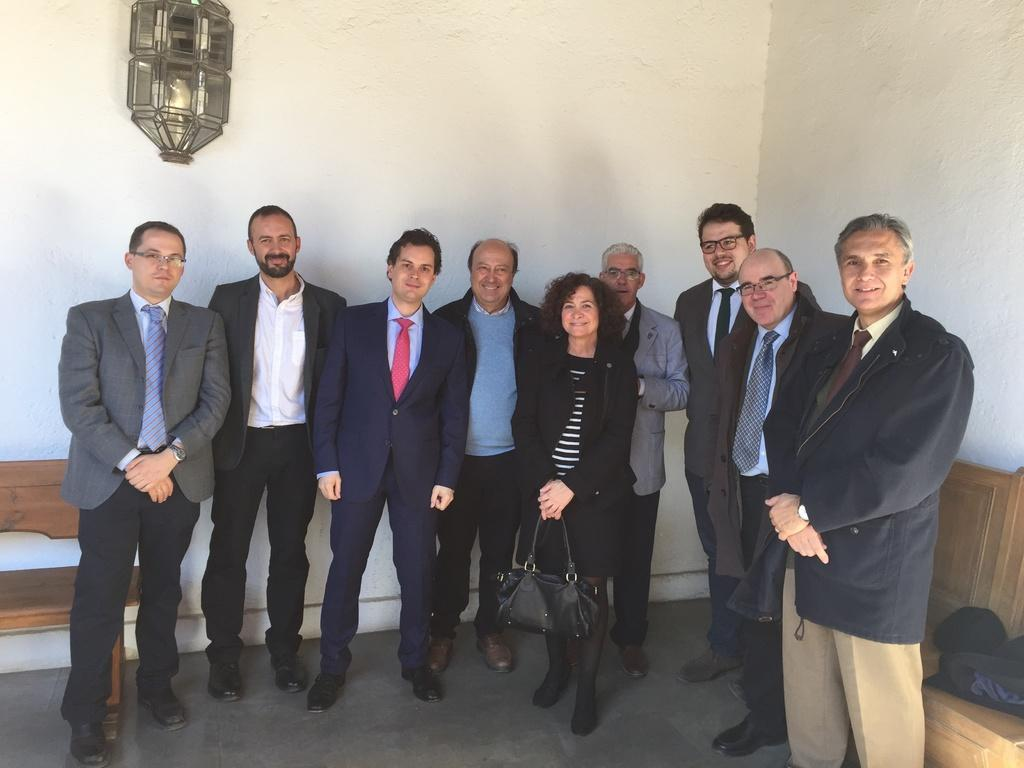What is happening in the image involving the group of people? The people are standing and posing for the picture. What type of furniture is present in the image? There are wooden benches in the image. What can be seen attached to the wall in the image? There is a wall with a lamp in the image. What type of spy equipment can be seen in the image? There is no spy equipment present in the image. What discovery was made by the group of people in the image? The image does not depict any discovery made by the group of people. 